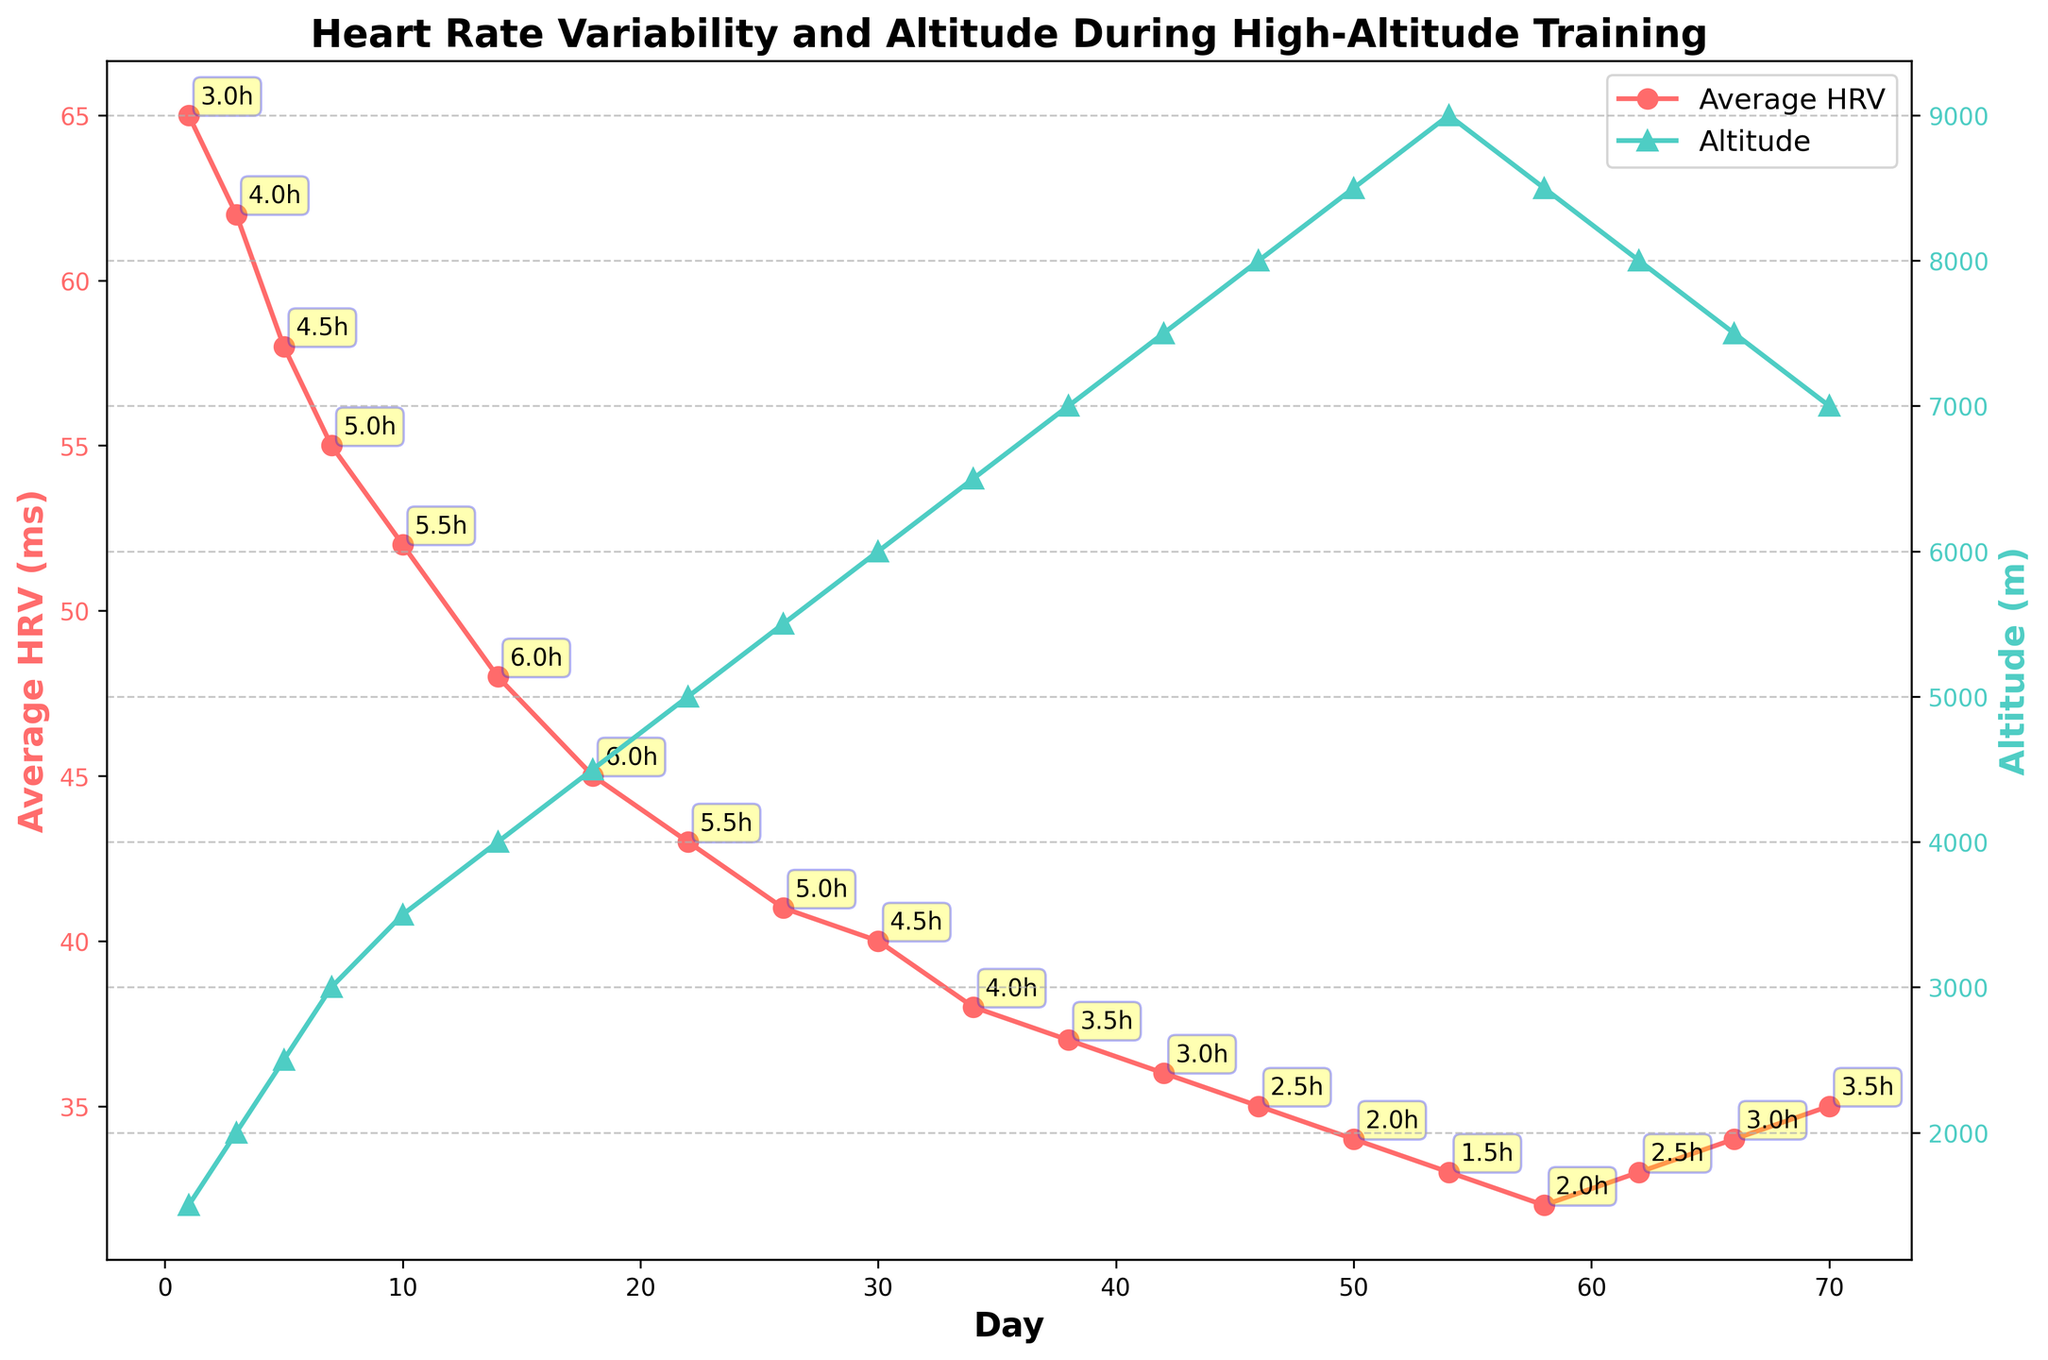What trend do you observe in Average HRV values over time? The Average HRV values show a general decreasing trend over time as indicated by the downward slope of the red line with circular markers.
Answer: Decreasing trend How does the altitude change over the course of the training period? The altitude increases steadily over the training period, reaching a peak at around Day 54 and then decreases slightly. This is shown by the green line with triangular markers.
Answer: Increases then decreases slightly Which day has the highest altitude and what is the Average HRV (ms) on that day? The highest altitude is on Day 54 with 9000 meters. The corresponding Average HRV on that day is 33 ms. This can be seen where the green line peaks and examining the red line's value at the same day.
Answer: Day 54, 33 ms What is the difference in Average HRV between Day 1 and Day 70? The Average HRV on Day 1 is 65 ms and on Day 70 is 35 ms. The difference is calculated as 65 - 35 = 30 ms.
Answer: 30 ms Compare the Average HRV and altitude trends. How do these trends relate to each other? As altitude increases, the Average HRV decreases. This inverse relationship is visualized by the red line trending downward as the green line trends upward, and vice versa.
Answer: Inverse relationship At what day does the Average HRV fall below 50 ms? The Average HRV falls below 50 ms on Day 14 as indicated by the red line crossing under the 50 ms mark.
Answer: Day 14 Between which two days is the drop in Average HRV the steepest? Between Day 1 (65 ms) and Day 3 (62 ms) and Day 14 (48 ms) and Day 18 (45 ms). The steepest overall drop is from Day 10 (52 ms) to Day 14 (48 ms) which is a drop of 4 ms.
Answer: Day 14 and Day 18 What is the training duration on the day with the lowest Average HRV? The lowest Average HRV is 32 ms, observed on Day 58 with a training duration of 2 hours.
Answer: 2 hours Which day has the longest training duration and what are the Average HRV and altitude on that day? The longest training duration is 6 hours, occurring on Day 14. On this day, the Average HRV is 48 ms and the altitude is 4000 meters.
Answer: Day 14, 48 ms, 4000 meters 